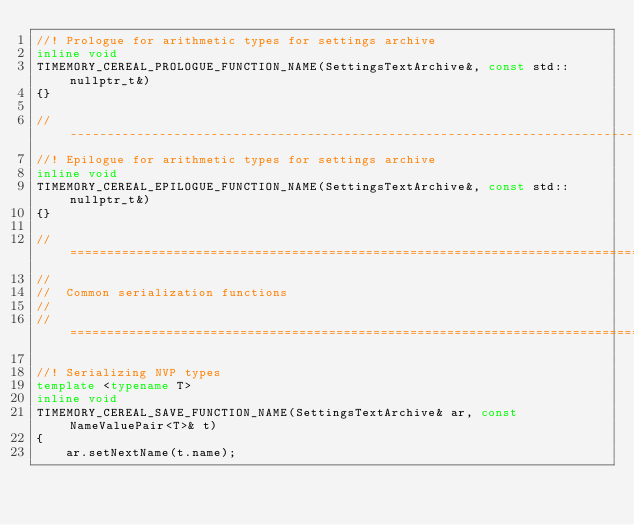Convert code to text. <code><loc_0><loc_0><loc_500><loc_500><_C++_>//! Prologue for arithmetic types for settings archive
inline void
TIMEMORY_CEREAL_PROLOGUE_FUNCTION_NAME(SettingsTextArchive&, const std::nullptr_t&)
{}

//--------------------------------------------------------------------------------------//
//! Epilogue for arithmetic types for settings archive
inline void
TIMEMORY_CEREAL_EPILOGUE_FUNCTION_NAME(SettingsTextArchive&, const std::nullptr_t&)
{}

//======================================================================================//
//
//  Common serialization functions
//
//======================================================================================//

//! Serializing NVP types
template <typename T>
inline void
TIMEMORY_CEREAL_SAVE_FUNCTION_NAME(SettingsTextArchive& ar, const NameValuePair<T>& t)
{
    ar.setNextName(t.name);</code> 